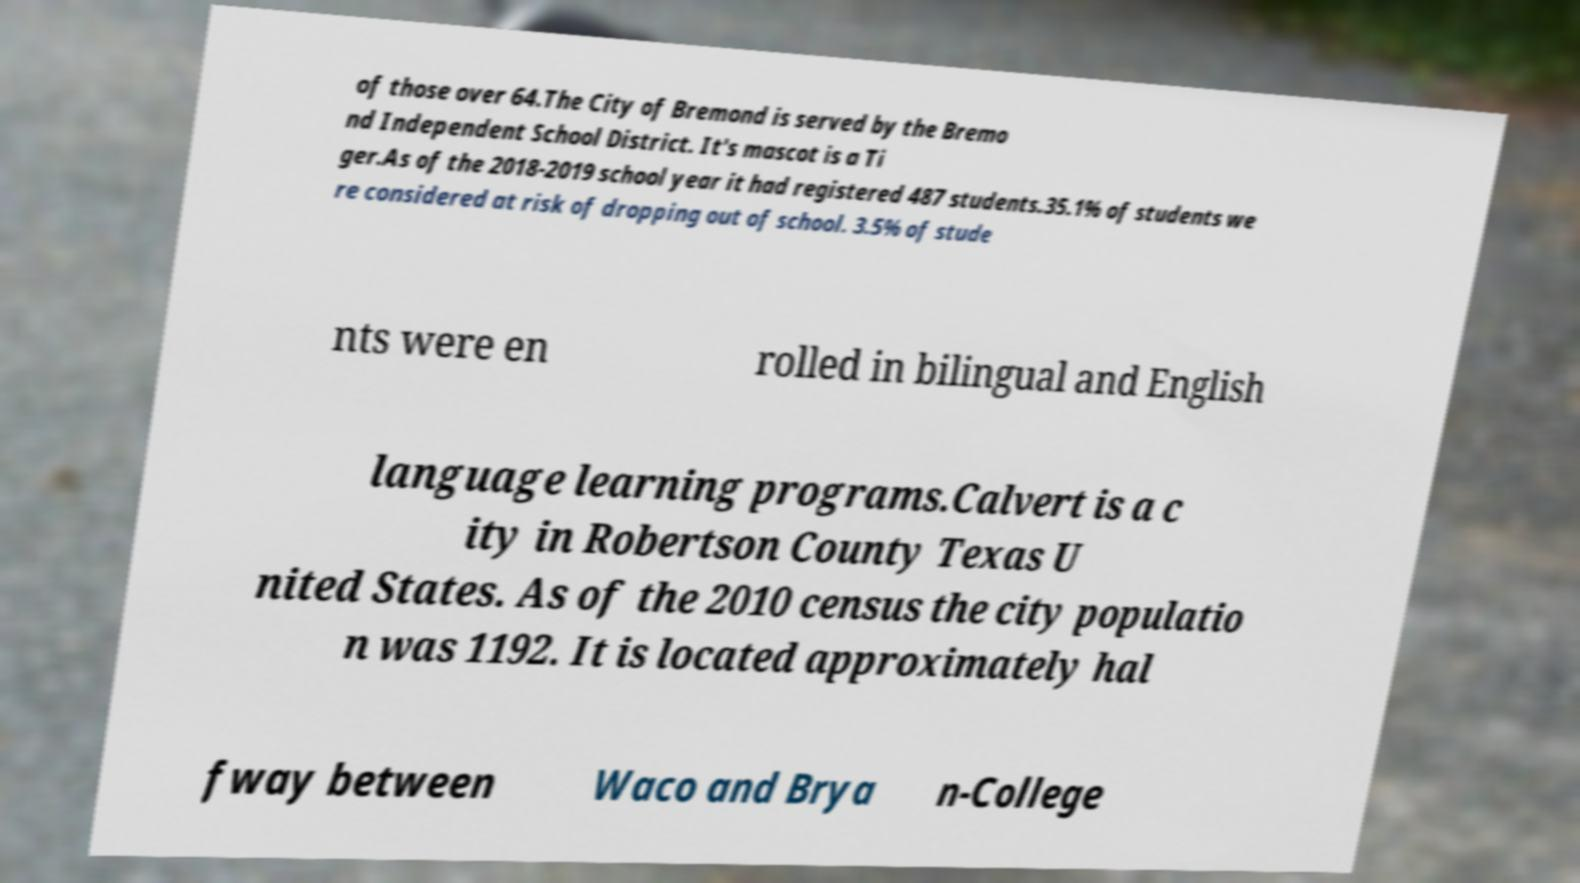There's text embedded in this image that I need extracted. Can you transcribe it verbatim? of those over 64.The City of Bremond is served by the Bremo nd Independent School District. It's mascot is a Ti ger.As of the 2018-2019 school year it had registered 487 students.35.1% of students we re considered at risk of dropping out of school. 3.5% of stude nts were en rolled in bilingual and English language learning programs.Calvert is a c ity in Robertson County Texas U nited States. As of the 2010 census the city populatio n was 1192. It is located approximately hal fway between Waco and Brya n-College 